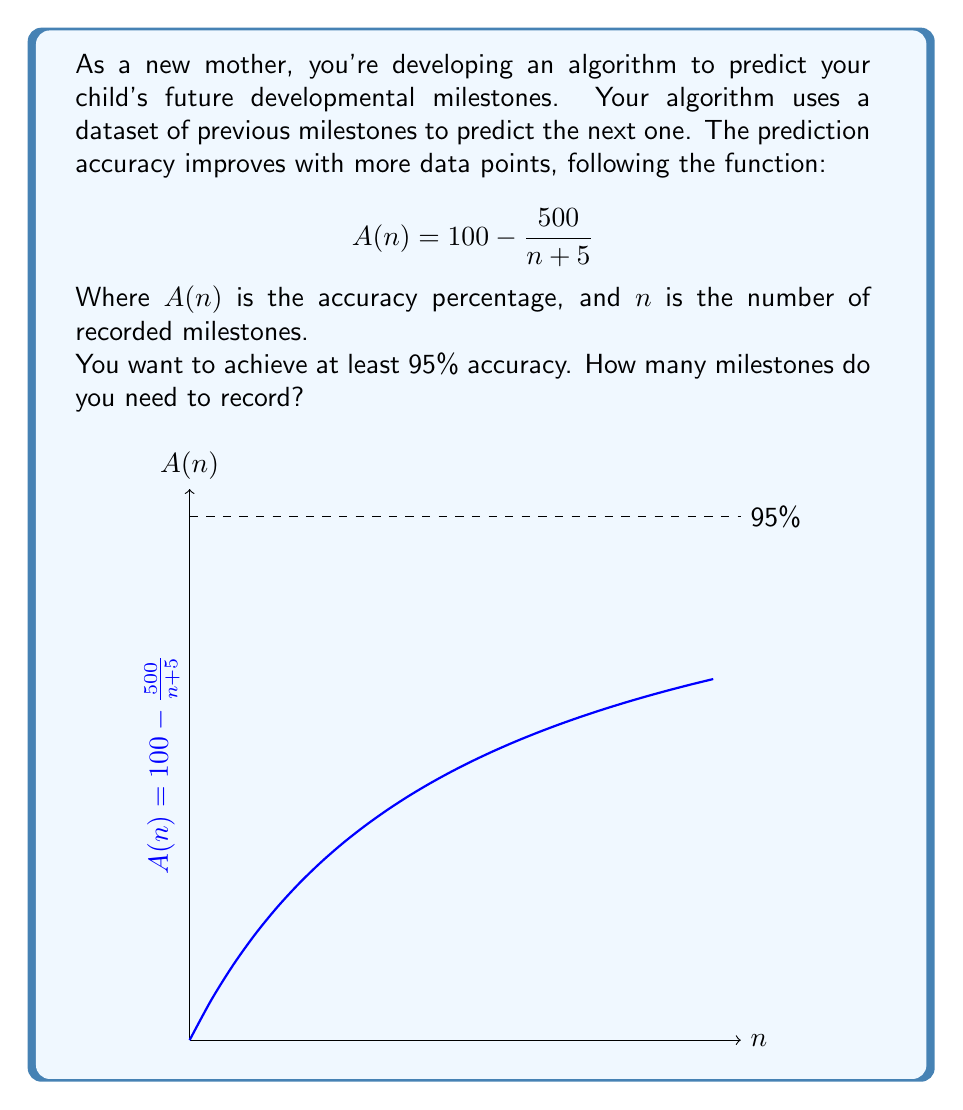Provide a solution to this math problem. Let's approach this step-by-step:

1) We need to find $n$ where $A(n) \geq 95$

2) Substituting this into our equation:

   $$95 \leq 100 - \frac{500}{n + 5}$$

3) Subtracting both sides from 100:

   $$5 \geq \frac{500}{n + 5}$$

4) Inverting both sides:

   $$\frac{1}{5} \leq \frac{n + 5}{500}$$

5) Multiplying both sides by 500:

   $$100 \leq n + 5$$

6) Subtracting 5 from both sides:

   $$95 \leq n$$

7) Since $n$ must be a whole number (we can't record a fractional milestone), we need the smallest integer greater than or equal to 95.
Answer: 95 milestones 